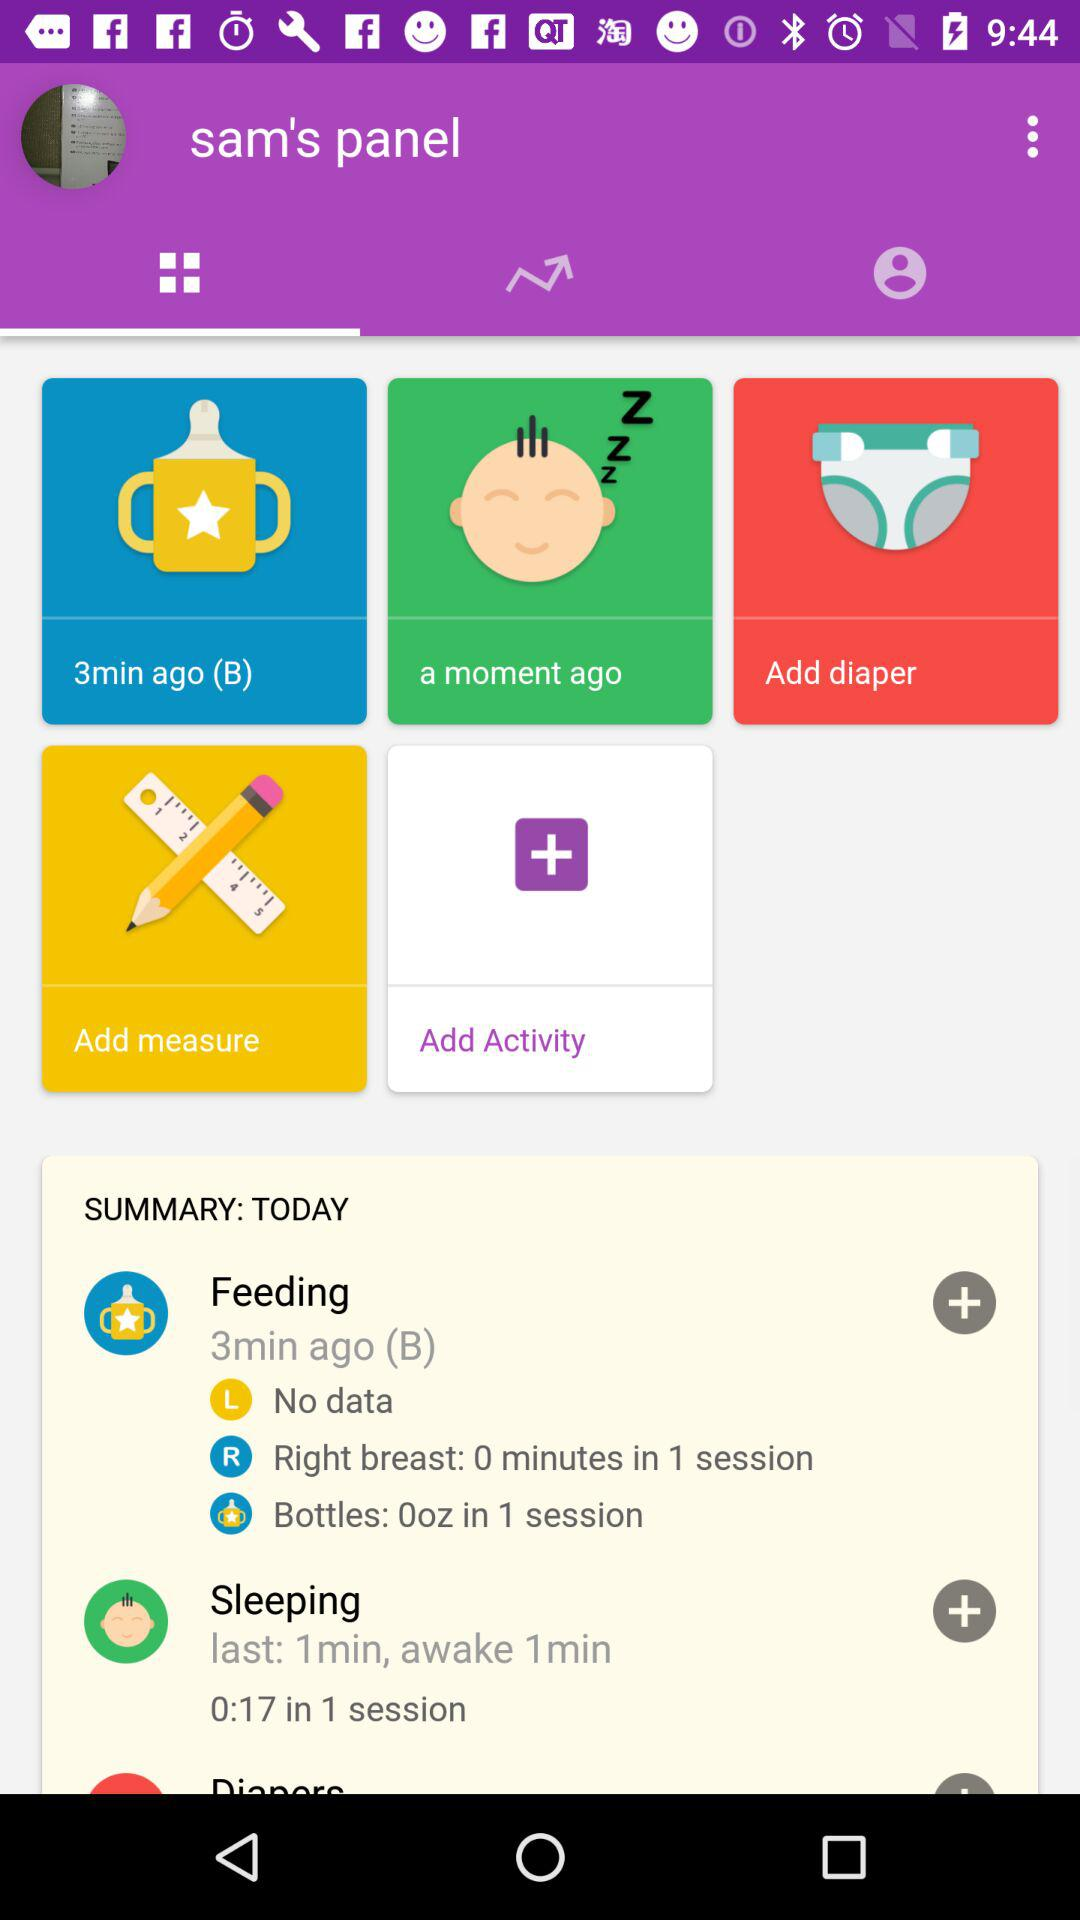How long ago was the feeding done for the baby? The feeding was done three minutes ago. 